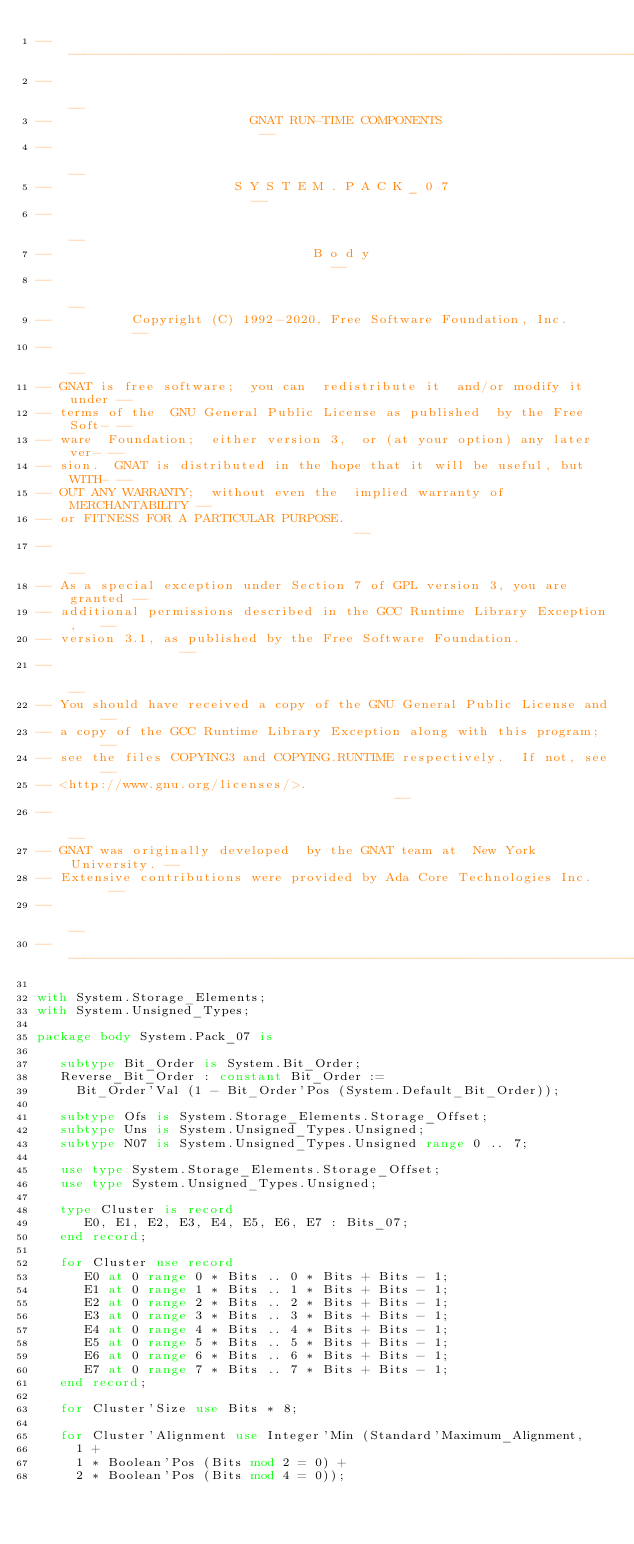<code> <loc_0><loc_0><loc_500><loc_500><_Ada_>------------------------------------------------------------------------------
--                                                                          --
--                         GNAT RUN-TIME COMPONENTS                         --
--                                                                          --
--                       S Y S T E M . P A C K _ 0 7                        --
--                                                                          --
--                                 B o d y                                  --
--                                                                          --
--          Copyright (C) 1992-2020, Free Software Foundation, Inc.         --
--                                                                          --
-- GNAT is free software;  you can  redistribute it  and/or modify it under --
-- terms of the  GNU General Public License as published  by the Free Soft- --
-- ware  Foundation;  either version 3,  or (at your option) any later ver- --
-- sion.  GNAT is distributed in the hope that it will be useful, but WITH- --
-- OUT ANY WARRANTY;  without even the  implied warranty of MERCHANTABILITY --
-- or FITNESS FOR A PARTICULAR PURPOSE.                                     --
--                                                                          --
-- As a special exception under Section 7 of GPL version 3, you are granted --
-- additional permissions described in the GCC Runtime Library Exception,   --
-- version 3.1, as published by the Free Software Foundation.               --
--                                                                          --
-- You should have received a copy of the GNU General Public License and    --
-- a copy of the GCC Runtime Library Exception along with this program;     --
-- see the files COPYING3 and COPYING.RUNTIME respectively.  If not, see    --
-- <http://www.gnu.org/licenses/>.                                          --
--                                                                          --
-- GNAT was originally developed  by the GNAT team at  New York University. --
-- Extensive contributions were provided by Ada Core Technologies Inc.      --
--                                                                          --
------------------------------------------------------------------------------

with System.Storage_Elements;
with System.Unsigned_Types;

package body System.Pack_07 is

   subtype Bit_Order is System.Bit_Order;
   Reverse_Bit_Order : constant Bit_Order :=
     Bit_Order'Val (1 - Bit_Order'Pos (System.Default_Bit_Order));

   subtype Ofs is System.Storage_Elements.Storage_Offset;
   subtype Uns is System.Unsigned_Types.Unsigned;
   subtype N07 is System.Unsigned_Types.Unsigned range 0 .. 7;

   use type System.Storage_Elements.Storage_Offset;
   use type System.Unsigned_Types.Unsigned;

   type Cluster is record
      E0, E1, E2, E3, E4, E5, E6, E7 : Bits_07;
   end record;

   for Cluster use record
      E0 at 0 range 0 * Bits .. 0 * Bits + Bits - 1;
      E1 at 0 range 1 * Bits .. 1 * Bits + Bits - 1;
      E2 at 0 range 2 * Bits .. 2 * Bits + Bits - 1;
      E3 at 0 range 3 * Bits .. 3 * Bits + Bits - 1;
      E4 at 0 range 4 * Bits .. 4 * Bits + Bits - 1;
      E5 at 0 range 5 * Bits .. 5 * Bits + Bits - 1;
      E6 at 0 range 6 * Bits .. 6 * Bits + Bits - 1;
      E7 at 0 range 7 * Bits .. 7 * Bits + Bits - 1;
   end record;

   for Cluster'Size use Bits * 8;

   for Cluster'Alignment use Integer'Min (Standard'Maximum_Alignment,
     1 +
     1 * Boolean'Pos (Bits mod 2 = 0) +
     2 * Boolean'Pos (Bits mod 4 = 0));</code> 